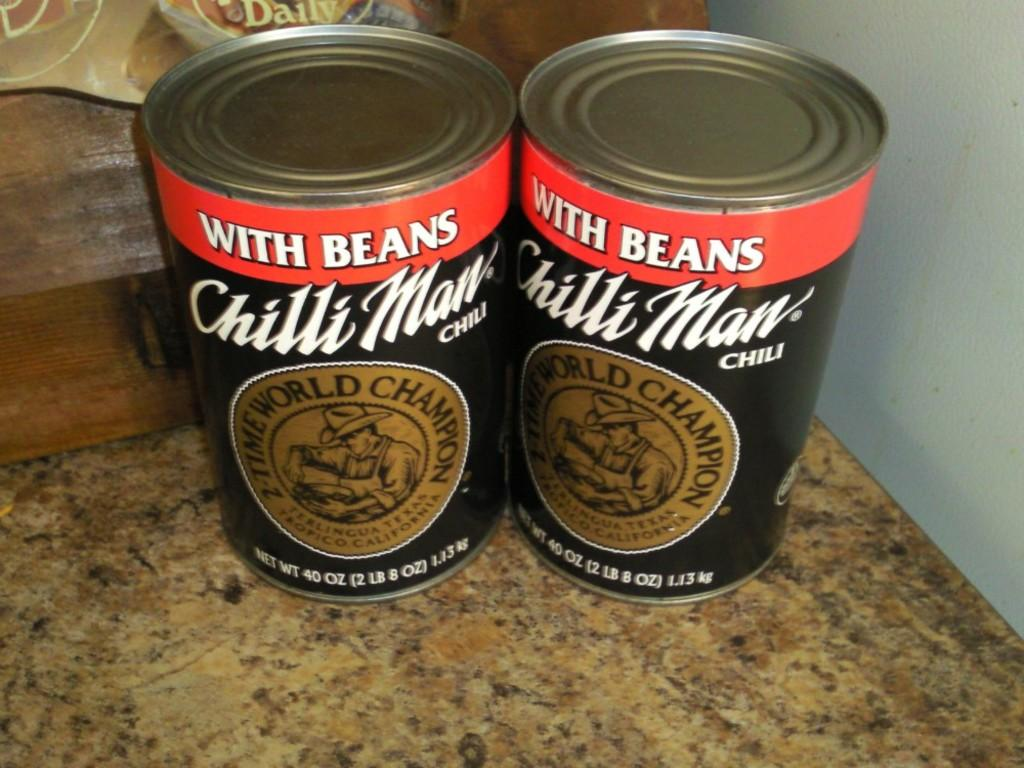<image>
Describe the image concisely. Two cans of Chilli Man Chili next to each other on a tan granite counter top. 